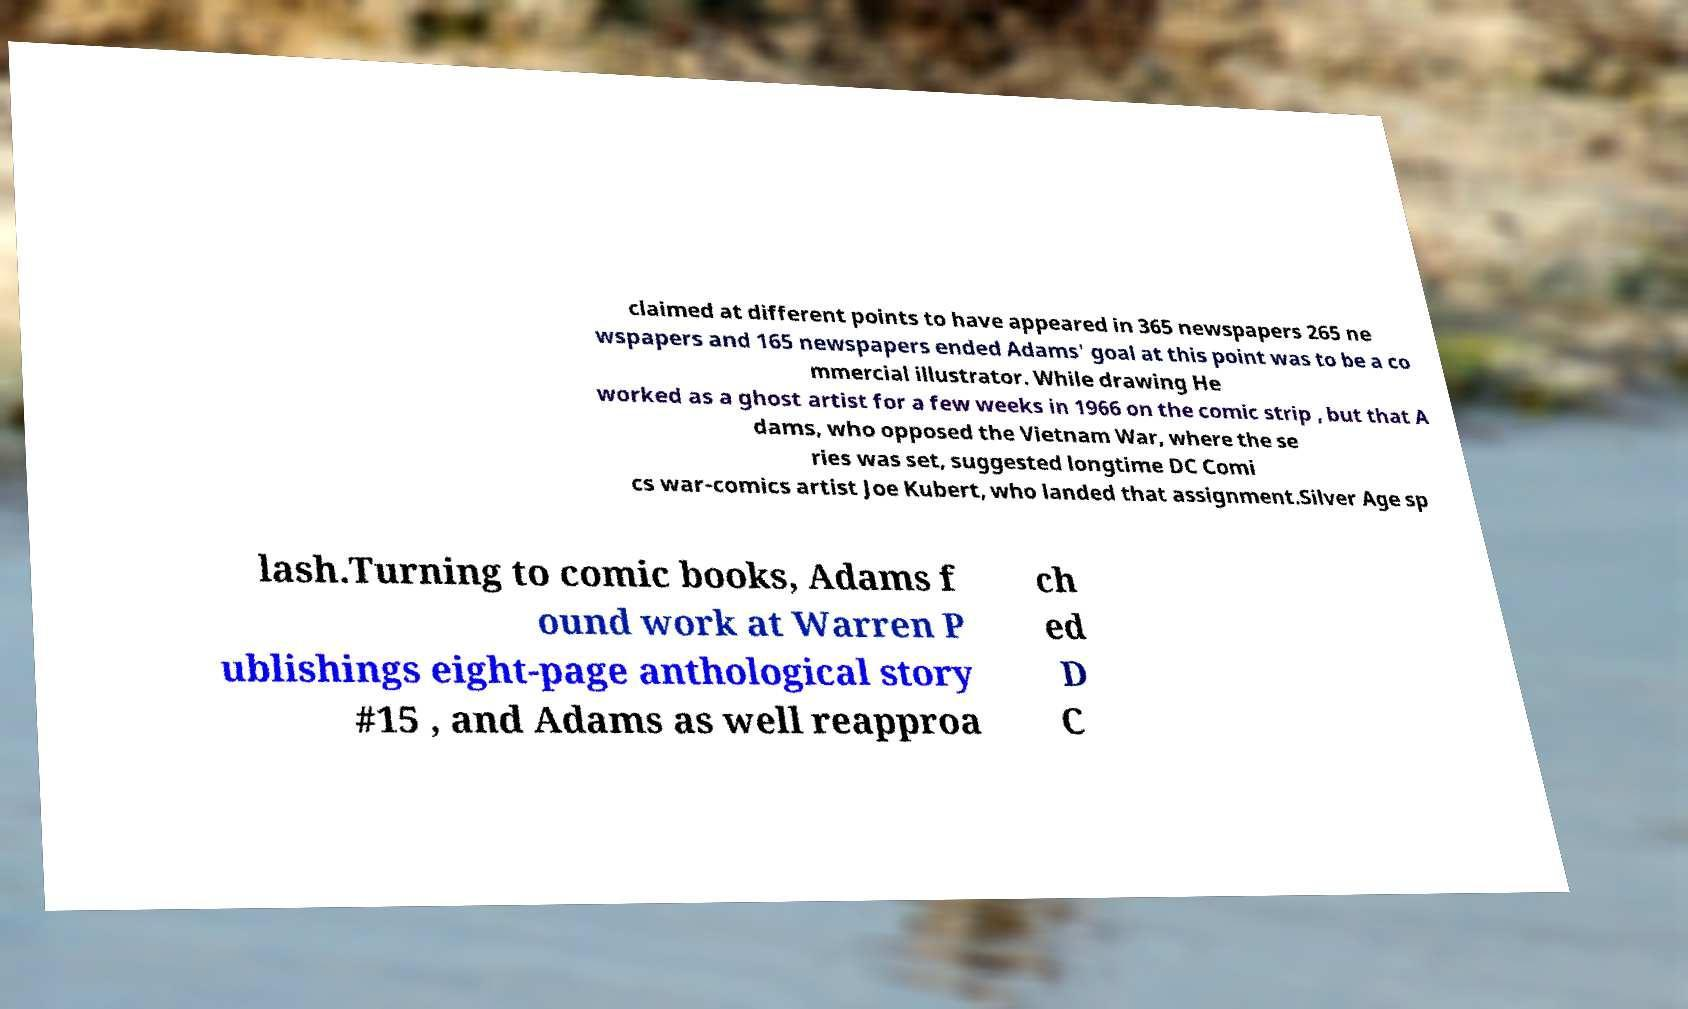What messages or text are displayed in this image? I need them in a readable, typed format. claimed at different points to have appeared in 365 newspapers 265 ne wspapers and 165 newspapers ended Adams' goal at this point was to be a co mmercial illustrator. While drawing He worked as a ghost artist for a few weeks in 1966 on the comic strip , but that A dams, who opposed the Vietnam War, where the se ries was set, suggested longtime DC Comi cs war-comics artist Joe Kubert, who landed that assignment.Silver Age sp lash.Turning to comic books, Adams f ound work at Warren P ublishings eight-page anthological story #15 , and Adams as well reapproa ch ed D C 